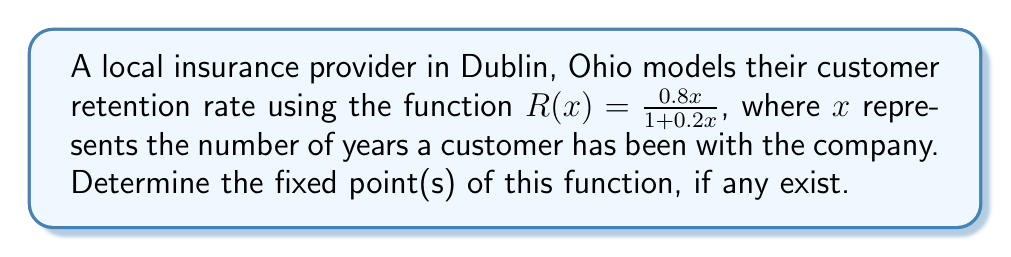Can you solve this math problem? To find the fixed point(s) of the function $R(x) = \frac{0.8x}{1 + 0.2x}$, we need to solve the equation $R(x) = x$. This means:

1) Set up the equation:
   $$\frac{0.8x}{1 + 0.2x} = x$$

2) Multiply both sides by $(1 + 0.2x)$:
   $$0.8x = x(1 + 0.2x)$$

3) Expand the right side:
   $$0.8x = x + 0.2x^2$$

4) Subtract $x$ from both sides:
   $$-0.2x = 0.2x^2$$

5) Factor out $0.2x$:
   $$0.2x(-1 - x) = 0$$

6) Solve for $x$:
   Either $0.2x = 0$ or $-1 - x = 0$
   
   $x = 0$ or $x = -1$

7) Check the domain:
   Since $x$ represents years, it must be non-negative. Therefore, $x = -1$ is not a valid solution in this context.

Thus, the only fixed point of this function is $x = 0$.
Answer: $x = 0$ 